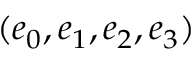<formula> <loc_0><loc_0><loc_500><loc_500>( e _ { 0 } , e _ { 1 } , e _ { 2 } , e _ { 3 } )</formula> 